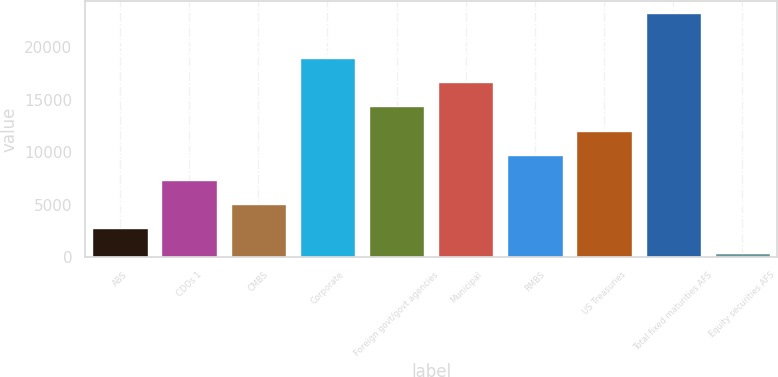Convert chart to OTSL. <chart><loc_0><loc_0><loc_500><loc_500><bar_chart><fcel>ABS<fcel>CDOs 1<fcel>CMBS<fcel>Corporate<fcel>Foreign govt/govt agencies<fcel>Municipal<fcel>RMBS<fcel>US Treasuries<fcel>Total fixed maturities AFS<fcel>Equity securities AFS<nl><fcel>2742.7<fcel>7390.1<fcel>5066.4<fcel>19008.6<fcel>14361.2<fcel>16684.9<fcel>9713.8<fcel>12037.5<fcel>23237<fcel>419<nl></chart> 